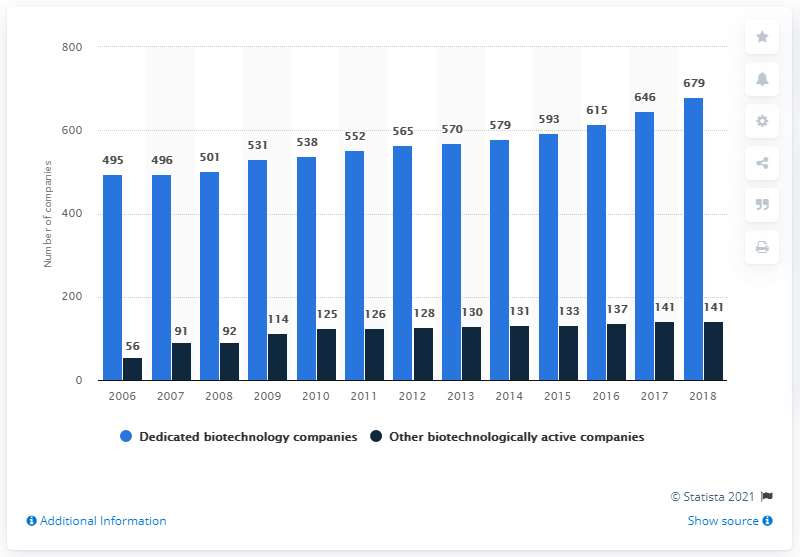What was the number of other biotechnologically active companies in Germany in 2018?
 141 